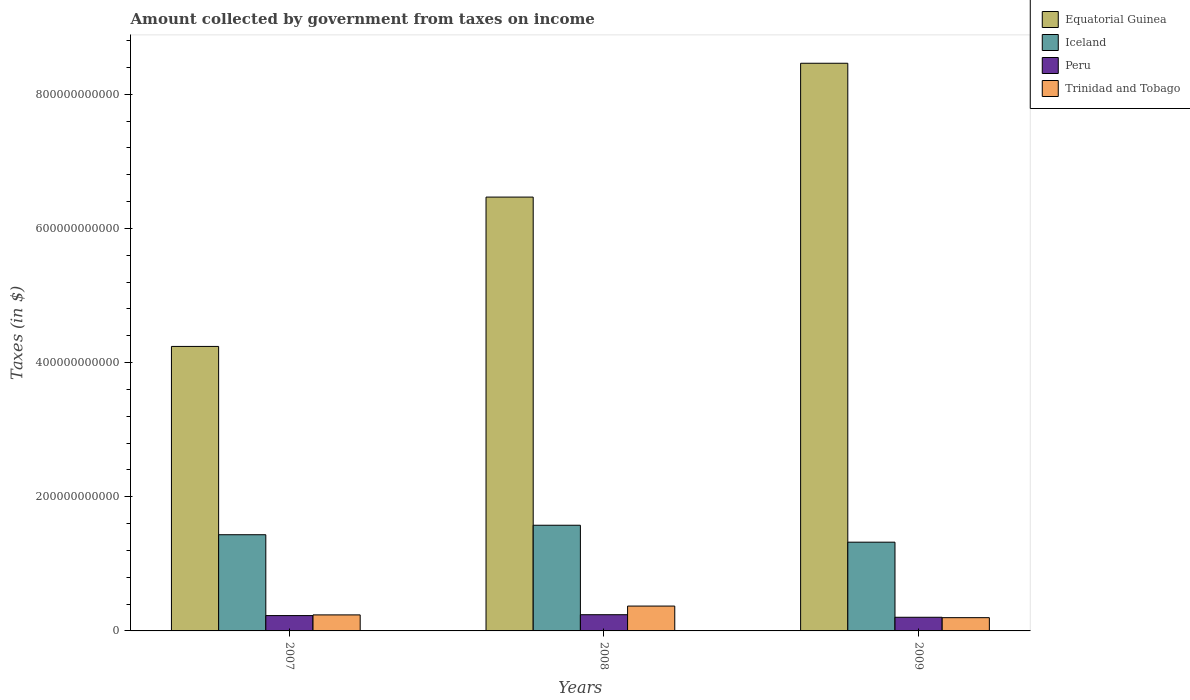How many different coloured bars are there?
Give a very brief answer. 4. How many bars are there on the 2nd tick from the right?
Make the answer very short. 4. What is the amount collected by government from taxes on income in Peru in 2008?
Your answer should be very brief. 2.42e+1. Across all years, what is the maximum amount collected by government from taxes on income in Trinidad and Tobago?
Ensure brevity in your answer.  3.71e+1. Across all years, what is the minimum amount collected by government from taxes on income in Peru?
Make the answer very short. 2.03e+1. What is the total amount collected by government from taxes on income in Trinidad and Tobago in the graph?
Provide a succinct answer. 8.07e+1. What is the difference between the amount collected by government from taxes on income in Equatorial Guinea in 2007 and that in 2009?
Your answer should be very brief. -4.22e+11. What is the difference between the amount collected by government from taxes on income in Trinidad and Tobago in 2008 and the amount collected by government from taxes on income in Peru in 2007?
Provide a succinct answer. 1.42e+1. What is the average amount collected by government from taxes on income in Iceland per year?
Your answer should be very brief. 1.44e+11. In the year 2009, what is the difference between the amount collected by government from taxes on income in Trinidad and Tobago and amount collected by government from taxes on income in Iceland?
Your response must be concise. -1.13e+11. In how many years, is the amount collected by government from taxes on income in Iceland greater than 440000000000 $?
Your answer should be very brief. 0. What is the ratio of the amount collected by government from taxes on income in Trinidad and Tobago in 2007 to that in 2008?
Give a very brief answer. 0.64. Is the amount collected by government from taxes on income in Peru in 2008 less than that in 2009?
Keep it short and to the point. No. What is the difference between the highest and the second highest amount collected by government from taxes on income in Trinidad and Tobago?
Provide a succinct answer. 1.32e+1. What is the difference between the highest and the lowest amount collected by government from taxes on income in Peru?
Provide a short and direct response. 3.81e+09. Is the sum of the amount collected by government from taxes on income in Trinidad and Tobago in 2007 and 2009 greater than the maximum amount collected by government from taxes on income in Peru across all years?
Provide a succinct answer. Yes. Is it the case that in every year, the sum of the amount collected by government from taxes on income in Trinidad and Tobago and amount collected by government from taxes on income in Peru is greater than the sum of amount collected by government from taxes on income in Equatorial Guinea and amount collected by government from taxes on income in Iceland?
Provide a succinct answer. No. What does the 1st bar from the left in 2009 represents?
Offer a very short reply. Equatorial Guinea. Is it the case that in every year, the sum of the amount collected by government from taxes on income in Iceland and amount collected by government from taxes on income in Equatorial Guinea is greater than the amount collected by government from taxes on income in Peru?
Your response must be concise. Yes. How many bars are there?
Provide a short and direct response. 12. How many years are there in the graph?
Your answer should be compact. 3. What is the difference between two consecutive major ticks on the Y-axis?
Your answer should be compact. 2.00e+11. Are the values on the major ticks of Y-axis written in scientific E-notation?
Your answer should be compact. No. Where does the legend appear in the graph?
Make the answer very short. Top right. How many legend labels are there?
Your answer should be compact. 4. What is the title of the graph?
Offer a very short reply. Amount collected by government from taxes on income. Does "Denmark" appear as one of the legend labels in the graph?
Provide a short and direct response. No. What is the label or title of the X-axis?
Make the answer very short. Years. What is the label or title of the Y-axis?
Provide a succinct answer. Taxes (in $). What is the Taxes (in $) in Equatorial Guinea in 2007?
Ensure brevity in your answer.  4.24e+11. What is the Taxes (in $) in Iceland in 2007?
Offer a very short reply. 1.43e+11. What is the Taxes (in $) in Peru in 2007?
Provide a succinct answer. 2.29e+1. What is the Taxes (in $) in Trinidad and Tobago in 2007?
Your response must be concise. 2.39e+1. What is the Taxes (in $) in Equatorial Guinea in 2008?
Provide a short and direct response. 6.47e+11. What is the Taxes (in $) of Iceland in 2008?
Keep it short and to the point. 1.58e+11. What is the Taxes (in $) in Peru in 2008?
Provide a short and direct response. 2.42e+1. What is the Taxes (in $) in Trinidad and Tobago in 2008?
Ensure brevity in your answer.  3.71e+1. What is the Taxes (in $) of Equatorial Guinea in 2009?
Ensure brevity in your answer.  8.46e+11. What is the Taxes (in $) in Iceland in 2009?
Provide a short and direct response. 1.32e+11. What is the Taxes (in $) in Peru in 2009?
Offer a terse response. 2.03e+1. What is the Taxes (in $) of Trinidad and Tobago in 2009?
Offer a very short reply. 1.98e+1. Across all years, what is the maximum Taxes (in $) in Equatorial Guinea?
Provide a succinct answer. 8.46e+11. Across all years, what is the maximum Taxes (in $) of Iceland?
Make the answer very short. 1.58e+11. Across all years, what is the maximum Taxes (in $) in Peru?
Your answer should be very brief. 2.42e+1. Across all years, what is the maximum Taxes (in $) of Trinidad and Tobago?
Make the answer very short. 3.71e+1. Across all years, what is the minimum Taxes (in $) of Equatorial Guinea?
Provide a succinct answer. 4.24e+11. Across all years, what is the minimum Taxes (in $) of Iceland?
Provide a succinct answer. 1.32e+11. Across all years, what is the minimum Taxes (in $) in Peru?
Provide a succinct answer. 2.03e+1. Across all years, what is the minimum Taxes (in $) of Trinidad and Tobago?
Ensure brevity in your answer.  1.98e+1. What is the total Taxes (in $) in Equatorial Guinea in the graph?
Provide a short and direct response. 1.92e+12. What is the total Taxes (in $) of Iceland in the graph?
Give a very brief answer. 4.33e+11. What is the total Taxes (in $) in Peru in the graph?
Provide a succinct answer. 6.74e+1. What is the total Taxes (in $) in Trinidad and Tobago in the graph?
Make the answer very short. 8.07e+1. What is the difference between the Taxes (in $) in Equatorial Guinea in 2007 and that in 2008?
Offer a very short reply. -2.23e+11. What is the difference between the Taxes (in $) in Iceland in 2007 and that in 2008?
Ensure brevity in your answer.  -1.41e+1. What is the difference between the Taxes (in $) in Peru in 2007 and that in 2008?
Your answer should be very brief. -1.30e+09. What is the difference between the Taxes (in $) of Trinidad and Tobago in 2007 and that in 2008?
Provide a succinct answer. -1.32e+1. What is the difference between the Taxes (in $) in Equatorial Guinea in 2007 and that in 2009?
Your answer should be compact. -4.22e+11. What is the difference between the Taxes (in $) in Iceland in 2007 and that in 2009?
Your response must be concise. 1.11e+1. What is the difference between the Taxes (in $) of Peru in 2007 and that in 2009?
Provide a short and direct response. 2.51e+09. What is the difference between the Taxes (in $) in Trinidad and Tobago in 2007 and that in 2009?
Your answer should be compact. 4.14e+09. What is the difference between the Taxes (in $) of Equatorial Guinea in 2008 and that in 2009?
Your answer should be very brief. -1.99e+11. What is the difference between the Taxes (in $) of Iceland in 2008 and that in 2009?
Your answer should be very brief. 2.52e+1. What is the difference between the Taxes (in $) in Peru in 2008 and that in 2009?
Give a very brief answer. 3.81e+09. What is the difference between the Taxes (in $) of Trinidad and Tobago in 2008 and that in 2009?
Your answer should be compact. 1.73e+1. What is the difference between the Taxes (in $) of Equatorial Guinea in 2007 and the Taxes (in $) of Iceland in 2008?
Make the answer very short. 2.67e+11. What is the difference between the Taxes (in $) of Equatorial Guinea in 2007 and the Taxes (in $) of Peru in 2008?
Your answer should be compact. 4.00e+11. What is the difference between the Taxes (in $) of Equatorial Guinea in 2007 and the Taxes (in $) of Trinidad and Tobago in 2008?
Provide a short and direct response. 3.87e+11. What is the difference between the Taxes (in $) of Iceland in 2007 and the Taxes (in $) of Peru in 2008?
Make the answer very short. 1.19e+11. What is the difference between the Taxes (in $) of Iceland in 2007 and the Taxes (in $) of Trinidad and Tobago in 2008?
Make the answer very short. 1.06e+11. What is the difference between the Taxes (in $) in Peru in 2007 and the Taxes (in $) in Trinidad and Tobago in 2008?
Keep it short and to the point. -1.42e+1. What is the difference between the Taxes (in $) of Equatorial Guinea in 2007 and the Taxes (in $) of Iceland in 2009?
Offer a terse response. 2.92e+11. What is the difference between the Taxes (in $) of Equatorial Guinea in 2007 and the Taxes (in $) of Peru in 2009?
Provide a succinct answer. 4.04e+11. What is the difference between the Taxes (in $) of Equatorial Guinea in 2007 and the Taxes (in $) of Trinidad and Tobago in 2009?
Give a very brief answer. 4.04e+11. What is the difference between the Taxes (in $) in Iceland in 2007 and the Taxes (in $) in Peru in 2009?
Keep it short and to the point. 1.23e+11. What is the difference between the Taxes (in $) of Iceland in 2007 and the Taxes (in $) of Trinidad and Tobago in 2009?
Offer a terse response. 1.24e+11. What is the difference between the Taxes (in $) of Peru in 2007 and the Taxes (in $) of Trinidad and Tobago in 2009?
Provide a short and direct response. 3.11e+09. What is the difference between the Taxes (in $) of Equatorial Guinea in 2008 and the Taxes (in $) of Iceland in 2009?
Provide a succinct answer. 5.14e+11. What is the difference between the Taxes (in $) in Equatorial Guinea in 2008 and the Taxes (in $) in Peru in 2009?
Make the answer very short. 6.26e+11. What is the difference between the Taxes (in $) in Equatorial Guinea in 2008 and the Taxes (in $) in Trinidad and Tobago in 2009?
Your answer should be compact. 6.27e+11. What is the difference between the Taxes (in $) in Iceland in 2008 and the Taxes (in $) in Peru in 2009?
Make the answer very short. 1.37e+11. What is the difference between the Taxes (in $) of Iceland in 2008 and the Taxes (in $) of Trinidad and Tobago in 2009?
Keep it short and to the point. 1.38e+11. What is the difference between the Taxes (in $) in Peru in 2008 and the Taxes (in $) in Trinidad and Tobago in 2009?
Offer a very short reply. 4.40e+09. What is the average Taxes (in $) in Equatorial Guinea per year?
Provide a succinct answer. 6.39e+11. What is the average Taxes (in $) in Iceland per year?
Give a very brief answer. 1.44e+11. What is the average Taxes (in $) of Peru per year?
Give a very brief answer. 2.25e+1. What is the average Taxes (in $) in Trinidad and Tobago per year?
Your answer should be very brief. 2.69e+1. In the year 2007, what is the difference between the Taxes (in $) in Equatorial Guinea and Taxes (in $) in Iceland?
Your response must be concise. 2.81e+11. In the year 2007, what is the difference between the Taxes (in $) in Equatorial Guinea and Taxes (in $) in Peru?
Ensure brevity in your answer.  4.01e+11. In the year 2007, what is the difference between the Taxes (in $) of Equatorial Guinea and Taxes (in $) of Trinidad and Tobago?
Give a very brief answer. 4.00e+11. In the year 2007, what is the difference between the Taxes (in $) of Iceland and Taxes (in $) of Peru?
Offer a terse response. 1.21e+11. In the year 2007, what is the difference between the Taxes (in $) in Iceland and Taxes (in $) in Trinidad and Tobago?
Your response must be concise. 1.19e+11. In the year 2007, what is the difference between the Taxes (in $) of Peru and Taxes (in $) of Trinidad and Tobago?
Your response must be concise. -1.03e+09. In the year 2008, what is the difference between the Taxes (in $) in Equatorial Guinea and Taxes (in $) in Iceland?
Offer a very short reply. 4.89e+11. In the year 2008, what is the difference between the Taxes (in $) of Equatorial Guinea and Taxes (in $) of Peru?
Your answer should be compact. 6.23e+11. In the year 2008, what is the difference between the Taxes (in $) of Equatorial Guinea and Taxes (in $) of Trinidad and Tobago?
Keep it short and to the point. 6.10e+11. In the year 2008, what is the difference between the Taxes (in $) in Iceland and Taxes (in $) in Peru?
Offer a terse response. 1.33e+11. In the year 2008, what is the difference between the Taxes (in $) of Iceland and Taxes (in $) of Trinidad and Tobago?
Give a very brief answer. 1.20e+11. In the year 2008, what is the difference between the Taxes (in $) of Peru and Taxes (in $) of Trinidad and Tobago?
Provide a succinct answer. -1.29e+1. In the year 2009, what is the difference between the Taxes (in $) in Equatorial Guinea and Taxes (in $) in Iceland?
Ensure brevity in your answer.  7.14e+11. In the year 2009, what is the difference between the Taxes (in $) of Equatorial Guinea and Taxes (in $) of Peru?
Offer a very short reply. 8.26e+11. In the year 2009, what is the difference between the Taxes (in $) of Equatorial Guinea and Taxes (in $) of Trinidad and Tobago?
Offer a terse response. 8.26e+11. In the year 2009, what is the difference between the Taxes (in $) in Iceland and Taxes (in $) in Peru?
Make the answer very short. 1.12e+11. In the year 2009, what is the difference between the Taxes (in $) in Iceland and Taxes (in $) in Trinidad and Tobago?
Keep it short and to the point. 1.13e+11. In the year 2009, what is the difference between the Taxes (in $) in Peru and Taxes (in $) in Trinidad and Tobago?
Offer a very short reply. 5.96e+08. What is the ratio of the Taxes (in $) in Equatorial Guinea in 2007 to that in 2008?
Keep it short and to the point. 0.66. What is the ratio of the Taxes (in $) of Iceland in 2007 to that in 2008?
Your answer should be compact. 0.91. What is the ratio of the Taxes (in $) in Peru in 2007 to that in 2008?
Provide a succinct answer. 0.95. What is the ratio of the Taxes (in $) of Trinidad and Tobago in 2007 to that in 2008?
Keep it short and to the point. 0.64. What is the ratio of the Taxes (in $) in Equatorial Guinea in 2007 to that in 2009?
Make the answer very short. 0.5. What is the ratio of the Taxes (in $) of Iceland in 2007 to that in 2009?
Your response must be concise. 1.08. What is the ratio of the Taxes (in $) of Peru in 2007 to that in 2009?
Your answer should be compact. 1.12. What is the ratio of the Taxes (in $) of Trinidad and Tobago in 2007 to that in 2009?
Provide a short and direct response. 1.21. What is the ratio of the Taxes (in $) in Equatorial Guinea in 2008 to that in 2009?
Provide a short and direct response. 0.76. What is the ratio of the Taxes (in $) of Iceland in 2008 to that in 2009?
Give a very brief answer. 1.19. What is the ratio of the Taxes (in $) of Peru in 2008 to that in 2009?
Your response must be concise. 1.19. What is the ratio of the Taxes (in $) in Trinidad and Tobago in 2008 to that in 2009?
Your answer should be very brief. 1.88. What is the difference between the highest and the second highest Taxes (in $) in Equatorial Guinea?
Your response must be concise. 1.99e+11. What is the difference between the highest and the second highest Taxes (in $) in Iceland?
Make the answer very short. 1.41e+1. What is the difference between the highest and the second highest Taxes (in $) in Peru?
Offer a very short reply. 1.30e+09. What is the difference between the highest and the second highest Taxes (in $) of Trinidad and Tobago?
Keep it short and to the point. 1.32e+1. What is the difference between the highest and the lowest Taxes (in $) in Equatorial Guinea?
Offer a terse response. 4.22e+11. What is the difference between the highest and the lowest Taxes (in $) in Iceland?
Provide a succinct answer. 2.52e+1. What is the difference between the highest and the lowest Taxes (in $) in Peru?
Your answer should be compact. 3.81e+09. What is the difference between the highest and the lowest Taxes (in $) in Trinidad and Tobago?
Your answer should be compact. 1.73e+1. 